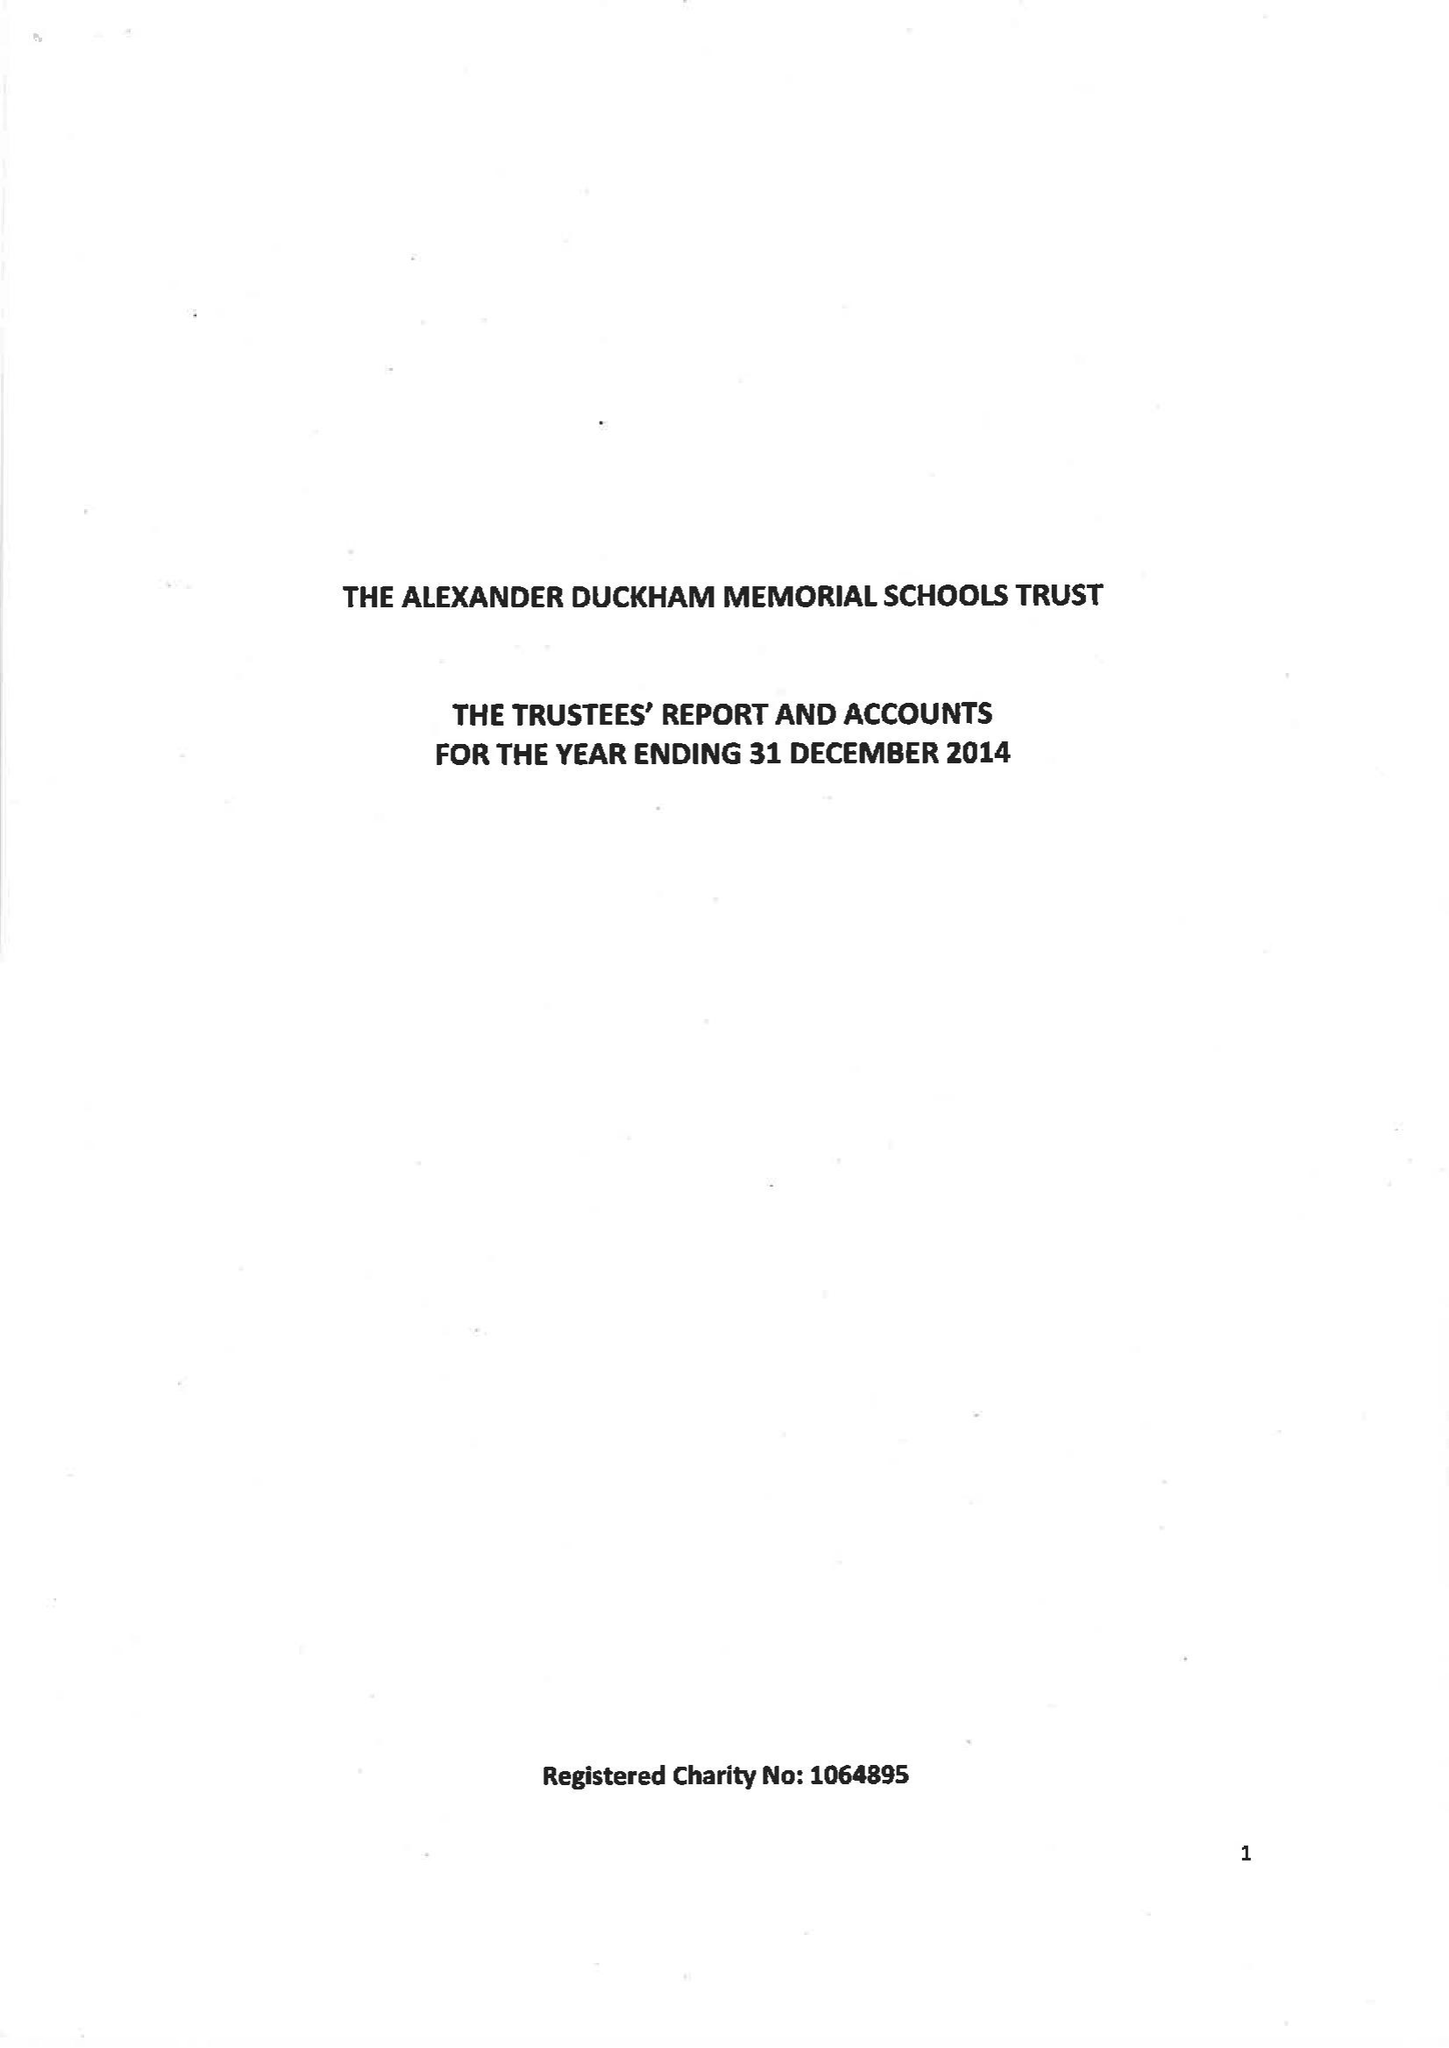What is the value for the charity_number?
Answer the question using a single word or phrase. 1064895 